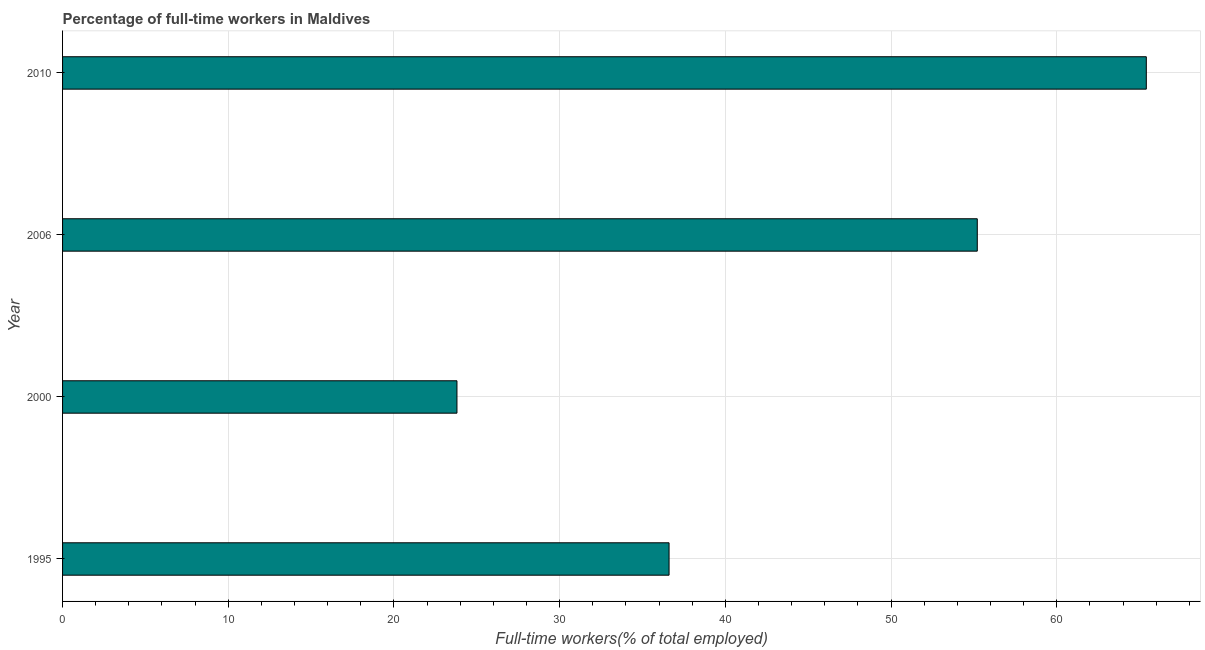Does the graph contain any zero values?
Give a very brief answer. No. Does the graph contain grids?
Your answer should be very brief. Yes. What is the title of the graph?
Your answer should be very brief. Percentage of full-time workers in Maldives. What is the label or title of the X-axis?
Give a very brief answer. Full-time workers(% of total employed). What is the label or title of the Y-axis?
Make the answer very short. Year. What is the percentage of full-time workers in 1995?
Keep it short and to the point. 36.6. Across all years, what is the maximum percentage of full-time workers?
Provide a succinct answer. 65.4. Across all years, what is the minimum percentage of full-time workers?
Ensure brevity in your answer.  23.8. In which year was the percentage of full-time workers minimum?
Provide a short and direct response. 2000. What is the sum of the percentage of full-time workers?
Ensure brevity in your answer.  181. What is the difference between the percentage of full-time workers in 2000 and 2010?
Provide a succinct answer. -41.6. What is the average percentage of full-time workers per year?
Your answer should be very brief. 45.25. What is the median percentage of full-time workers?
Provide a short and direct response. 45.9. Do a majority of the years between 2000 and 2006 (inclusive) have percentage of full-time workers greater than 2 %?
Your answer should be compact. Yes. What is the ratio of the percentage of full-time workers in 1995 to that in 2006?
Offer a terse response. 0.66. Is the percentage of full-time workers in 1995 less than that in 2006?
Your response must be concise. Yes. What is the difference between the highest and the lowest percentage of full-time workers?
Your answer should be very brief. 41.6. In how many years, is the percentage of full-time workers greater than the average percentage of full-time workers taken over all years?
Ensure brevity in your answer.  2. How many bars are there?
Offer a terse response. 4. Are all the bars in the graph horizontal?
Keep it short and to the point. Yes. How many years are there in the graph?
Your answer should be very brief. 4. What is the difference between two consecutive major ticks on the X-axis?
Give a very brief answer. 10. Are the values on the major ticks of X-axis written in scientific E-notation?
Provide a succinct answer. No. What is the Full-time workers(% of total employed) of 1995?
Your response must be concise. 36.6. What is the Full-time workers(% of total employed) of 2000?
Offer a very short reply. 23.8. What is the Full-time workers(% of total employed) in 2006?
Provide a short and direct response. 55.2. What is the Full-time workers(% of total employed) of 2010?
Keep it short and to the point. 65.4. What is the difference between the Full-time workers(% of total employed) in 1995 and 2006?
Provide a succinct answer. -18.6. What is the difference between the Full-time workers(% of total employed) in 1995 and 2010?
Your answer should be compact. -28.8. What is the difference between the Full-time workers(% of total employed) in 2000 and 2006?
Make the answer very short. -31.4. What is the difference between the Full-time workers(% of total employed) in 2000 and 2010?
Your response must be concise. -41.6. What is the difference between the Full-time workers(% of total employed) in 2006 and 2010?
Ensure brevity in your answer.  -10.2. What is the ratio of the Full-time workers(% of total employed) in 1995 to that in 2000?
Give a very brief answer. 1.54. What is the ratio of the Full-time workers(% of total employed) in 1995 to that in 2006?
Your answer should be very brief. 0.66. What is the ratio of the Full-time workers(% of total employed) in 1995 to that in 2010?
Your answer should be very brief. 0.56. What is the ratio of the Full-time workers(% of total employed) in 2000 to that in 2006?
Keep it short and to the point. 0.43. What is the ratio of the Full-time workers(% of total employed) in 2000 to that in 2010?
Keep it short and to the point. 0.36. What is the ratio of the Full-time workers(% of total employed) in 2006 to that in 2010?
Keep it short and to the point. 0.84. 